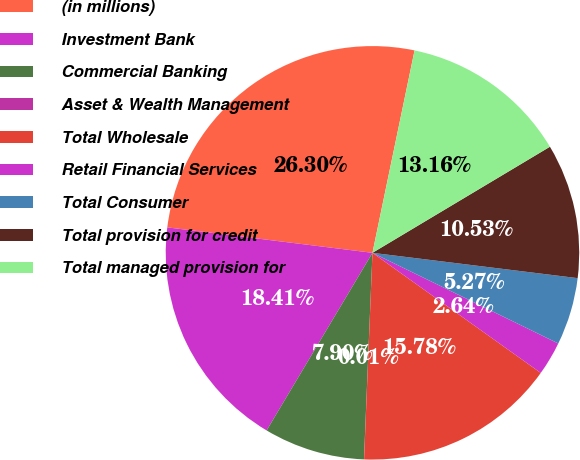Convert chart. <chart><loc_0><loc_0><loc_500><loc_500><pie_chart><fcel>(in millions)<fcel>Investment Bank<fcel>Commercial Banking<fcel>Asset & Wealth Management<fcel>Total Wholesale<fcel>Retail Financial Services<fcel>Total Consumer<fcel>Total provision for credit<fcel>Total managed provision for<nl><fcel>26.3%<fcel>18.41%<fcel>7.9%<fcel>0.01%<fcel>15.78%<fcel>2.64%<fcel>5.27%<fcel>10.53%<fcel>13.16%<nl></chart> 